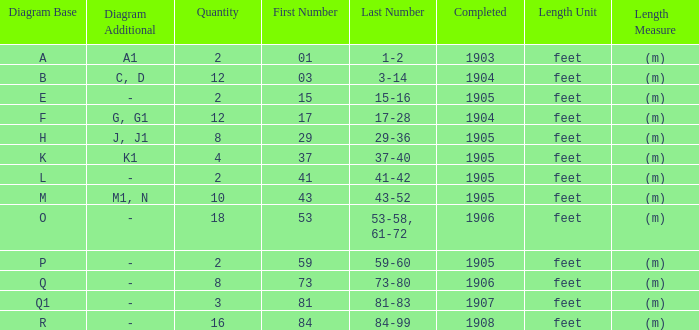What is the quantity of the item with the numbers of 29-36? 8.0. Would you mind parsing the complete table? {'header': ['Diagram Base', 'Diagram Additional', 'Quantity', 'First Number', 'Last Number', 'Completed', 'Length Unit', 'Length Measure'], 'rows': [['A', 'A1', '2', '01', '1-2', '1903', 'feet', '(m)'], ['B', 'C, D', '12', '03', '3-14', '1904', 'feet', '(m)'], ['E', '-', '2', '15', '15-16', '1905', 'feet', '(m)'], ['F', 'G, G1', '12', '17', '17-28', '1904', 'feet', '(m)'], ['H', 'J, J1', '8', '29', '29-36', '1905', 'feet', '(m)'], ['K', 'K1', '4', '37', '37-40', '1905', 'feet', '(m)'], ['L', '-', '2', '41', '41-42', '1905', 'feet', '(m)'], ['M', 'M1, N', '10', '43', '43-52', '1905', 'feet', '(m)'], ['O', '-', '18', '53', '53-58, 61-72', '1906', 'feet', '(m)'], ['P', '-', '2', '59', '59-60', '1905', 'feet', '(m)'], ['Q', '-', '8', '73', '73-80', '1906', 'feet', '(m)'], ['Q1', '-', '3', '81', '81-83', '1907', 'feet', '(m)'], ['R', '-', '16', '84', '84-99', '1908', 'feet', '(m)']]} 